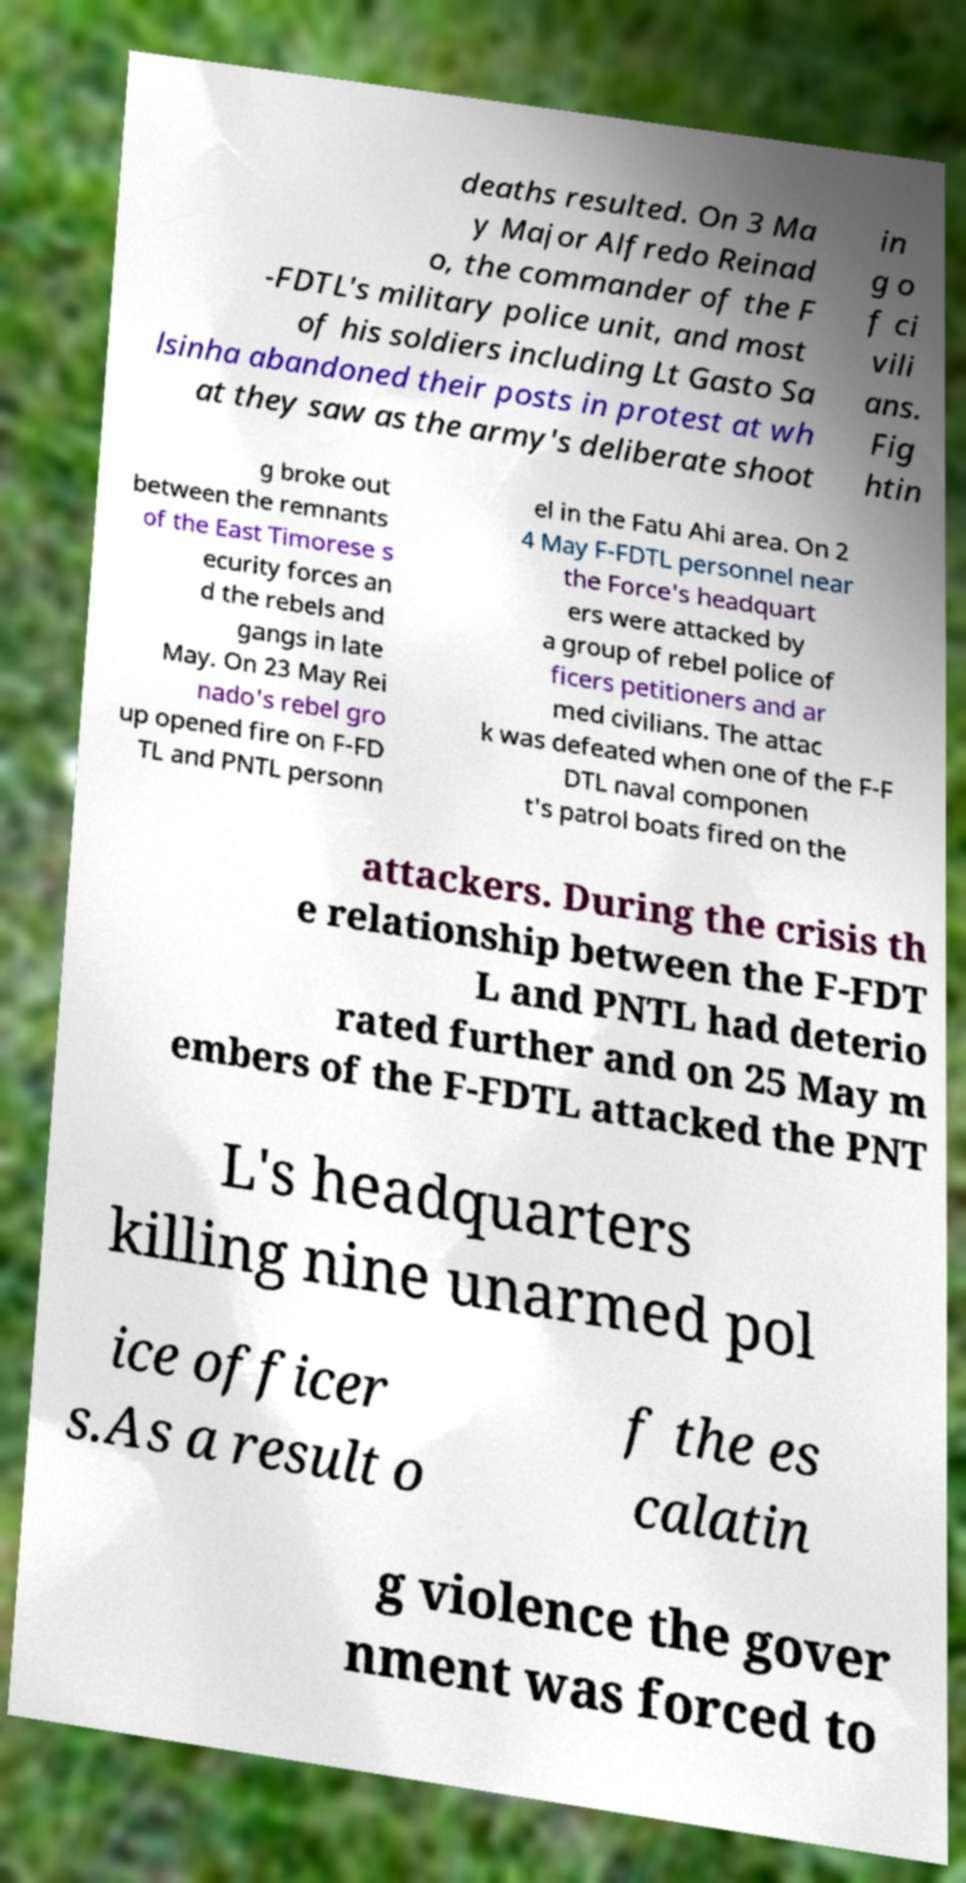Could you extract and type out the text from this image? deaths resulted. On 3 Ma y Major Alfredo Reinad o, the commander of the F -FDTL's military police unit, and most of his soldiers including Lt Gasto Sa lsinha abandoned their posts in protest at wh at they saw as the army's deliberate shoot in g o f ci vili ans. Fig htin g broke out between the remnants of the East Timorese s ecurity forces an d the rebels and gangs in late May. On 23 May Rei nado's rebel gro up opened fire on F-FD TL and PNTL personn el in the Fatu Ahi area. On 2 4 May F-FDTL personnel near the Force's headquart ers were attacked by a group of rebel police of ficers petitioners and ar med civilians. The attac k was defeated when one of the F-F DTL naval componen t's patrol boats fired on the attackers. During the crisis th e relationship between the F-FDT L and PNTL had deterio rated further and on 25 May m embers of the F-FDTL attacked the PNT L's headquarters killing nine unarmed pol ice officer s.As a result o f the es calatin g violence the gover nment was forced to 